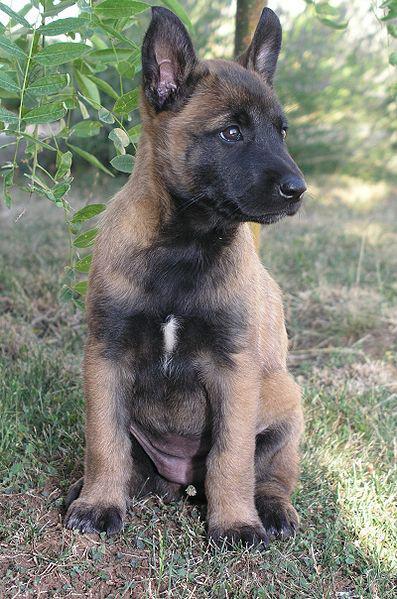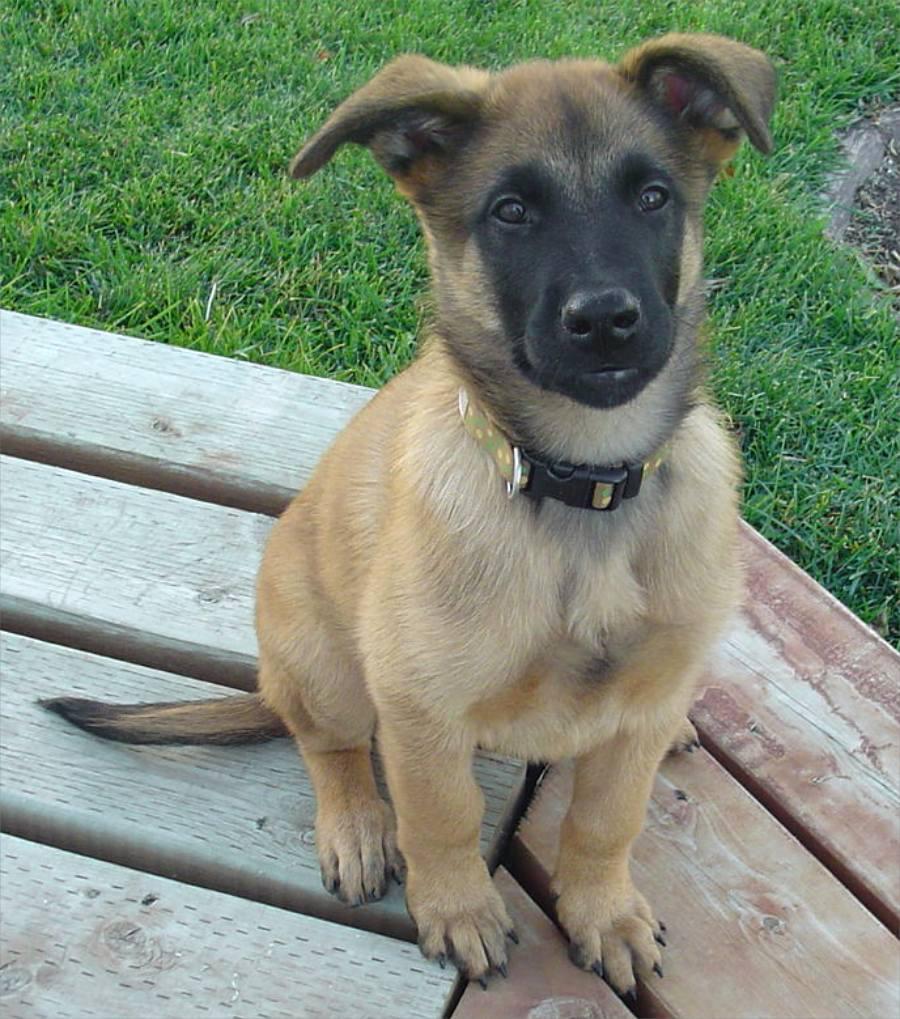The first image is the image on the left, the second image is the image on the right. Examine the images to the left and right. Is the description "There is at least one dog sitting down" accurate? Answer yes or no. Yes. 